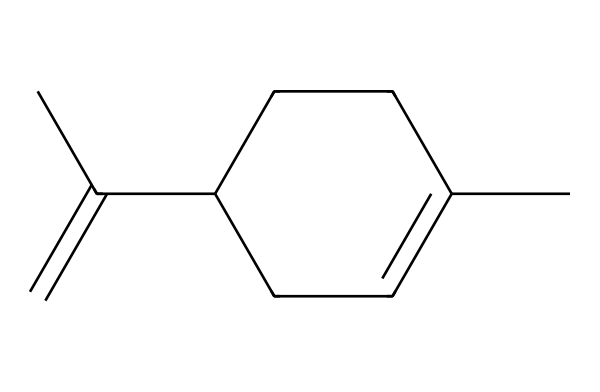What is the molecular formula of limonene? By analyzing the provided SMILES representation, we can count the number of carbon (C) and hydrogen (H) atoms. The structure indicates a total of 10 carbon atoms and 16 hydrogen atoms, which gives the molecular formula C10H16.
Answer: C10H16 How many rings are in the limonene structure? The SMILES representation shows a six-membered carbon ring (CC1=CCC(CC1)) indicating that limonene has one ring in its structure.
Answer: 1 What is the main functional group present in limonene? The structure indicates a double bond (C=C) between two of the carbon atoms, which signifies that the main functional group in limonene is an alkene.
Answer: alkene What type of compound is limonene classified as? Given the presence of a cyclic structure and the double bond, limonene falls under the category of terpenes, specifically a monocyclic terpene due to having one ring.
Answer: terpene How many double bonds does limonene have? In the SMILES representation, there is one instance of a double bond (indicated by '=') in the structure, confirming that limonene contains one double bond.
Answer: 1 What type of isomerism is represented by limonene? The SMILES structure suggests that limonene can exhibit geometric isomerism due to its double bond, allowing for cis and trans configurations. Therefore, limonene can exist as both forms.
Answer: geometric isomerism 